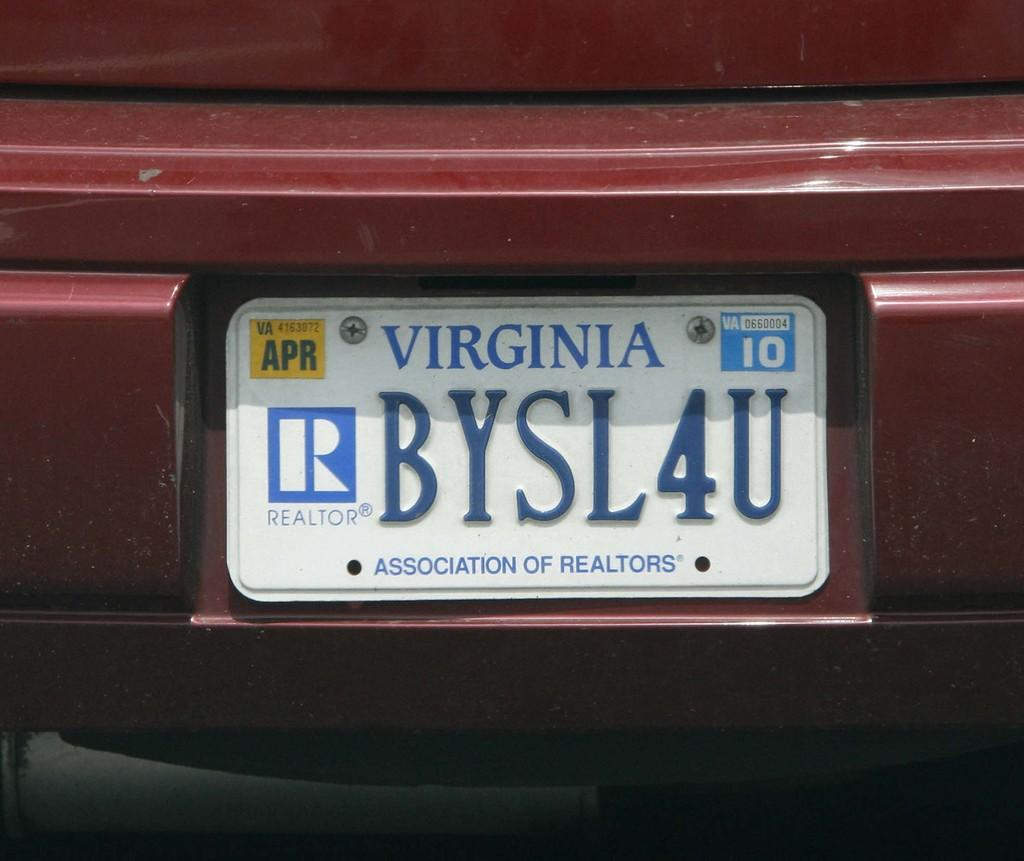<image>
Provide a brief description of the given image. A Virginia license plate from the Association of Realtors has a big R on the left side. 